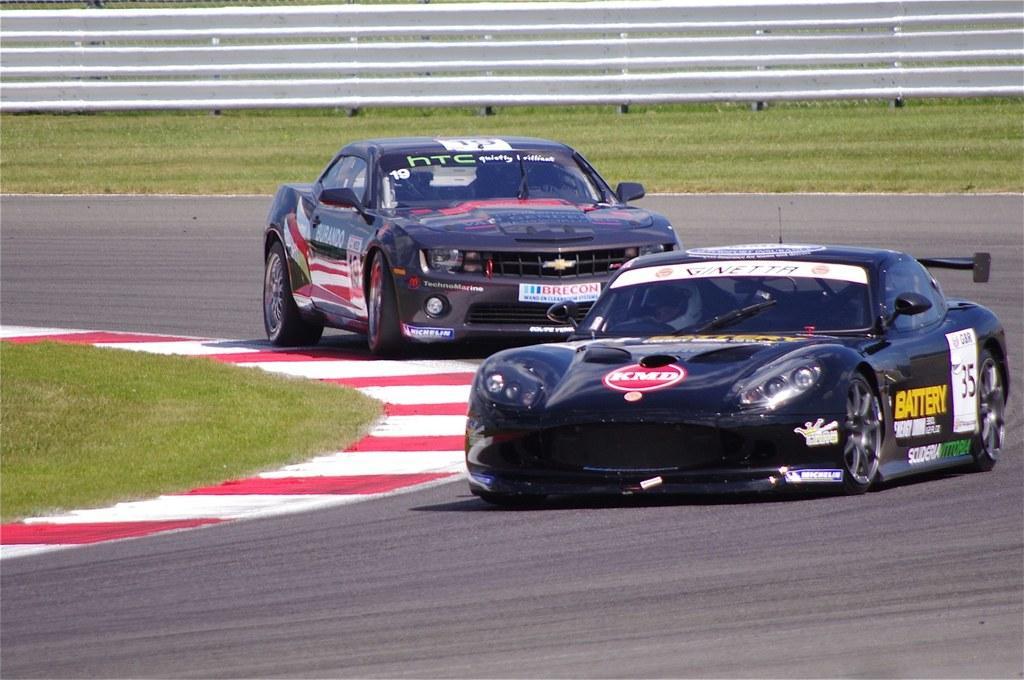In one or two sentences, can you explain what this image depicts? In this image, we can see vehicles on the road. In the background, there is a fence and we can see ground. 